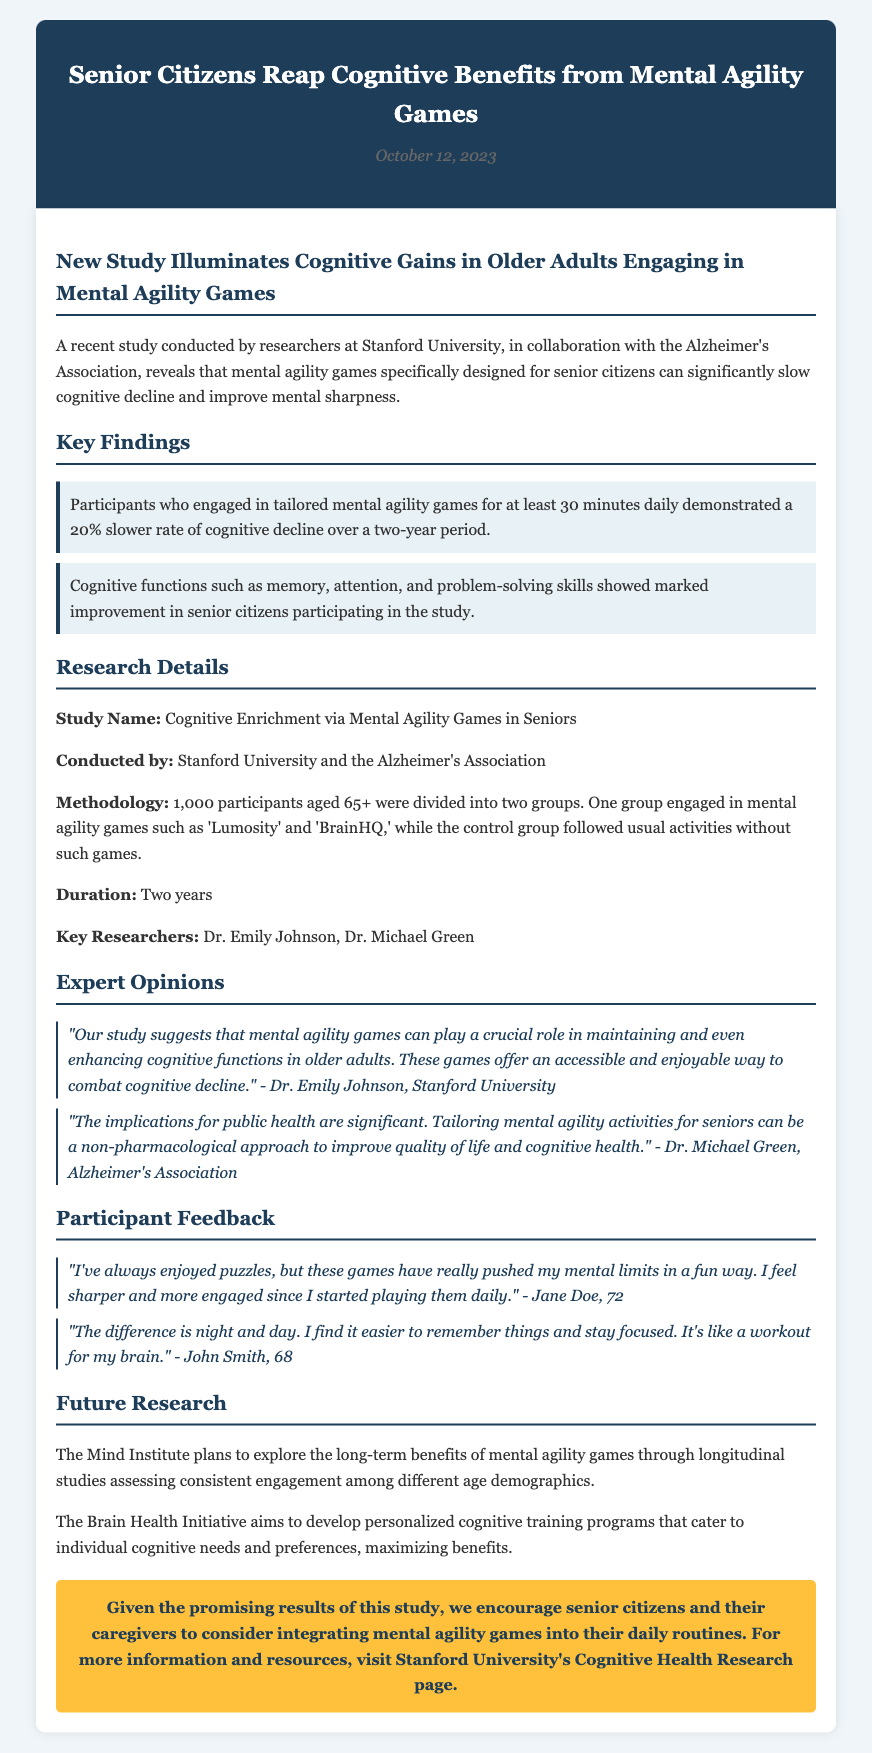What is the name of the study? The study name is mentioned in the research details section of the document.
Answer: Cognitive Enrichment via Mental Agility Games in Seniors Who conducted the study? The document lists the organizations responsible for conducting the study.
Answer: Stanford University and the Alzheimer's Association What is the age range of the participants? The document specifies the age of the participants involved in the study.
Answer: 65+ What percentage slower was the cognitive decline? The findings reveal a specific percentage related to the slow rate of cognitive decline observed.
Answer: 20% Who is one of the key researchers? The document specifically names one of the key researchers involved in this study.
Answer: Dr. Emily Johnson What cognitive functions improved according to the study? The document mentions specific cognitive functions that showed improvement among participants.
Answer: Memory, attention, and problem-solving skills What was the duration of the study? The document provides the time frame in which the study was conducted.
Answer: Two years What type of games were participants engaging in? The document provides examples of the types of games used in the study.
Answer: Mental agility games What is one participant's feedback about the games? The document features a direct quote from a participant reflecting their experience.
Answer: "I find it easier to remember things and stay focused." 